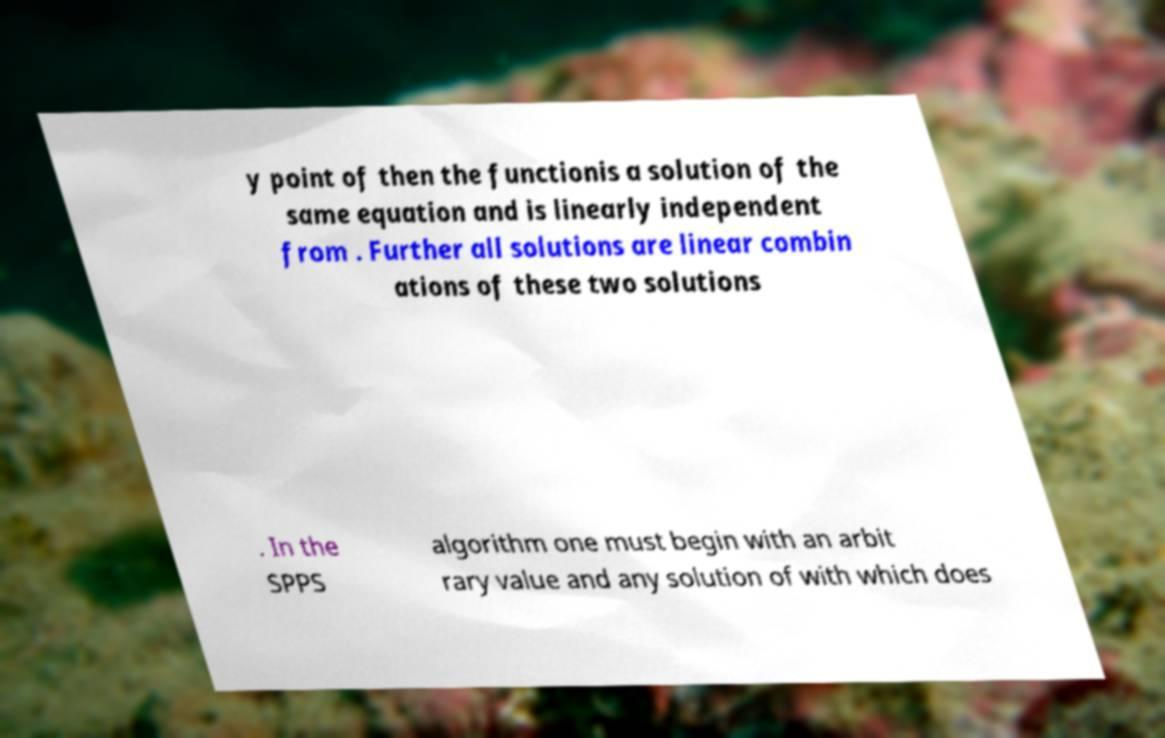I need the written content from this picture converted into text. Can you do that? y point of then the functionis a solution of the same equation and is linearly independent from . Further all solutions are linear combin ations of these two solutions . In the SPPS algorithm one must begin with an arbit rary value and any solution of with which does 